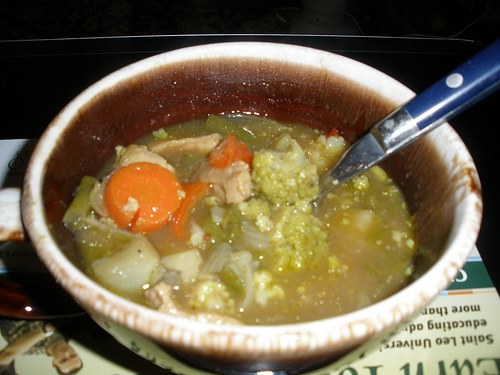What vegetable is left of the spoon? The vegetable to the left of the spoon is a carrot. 